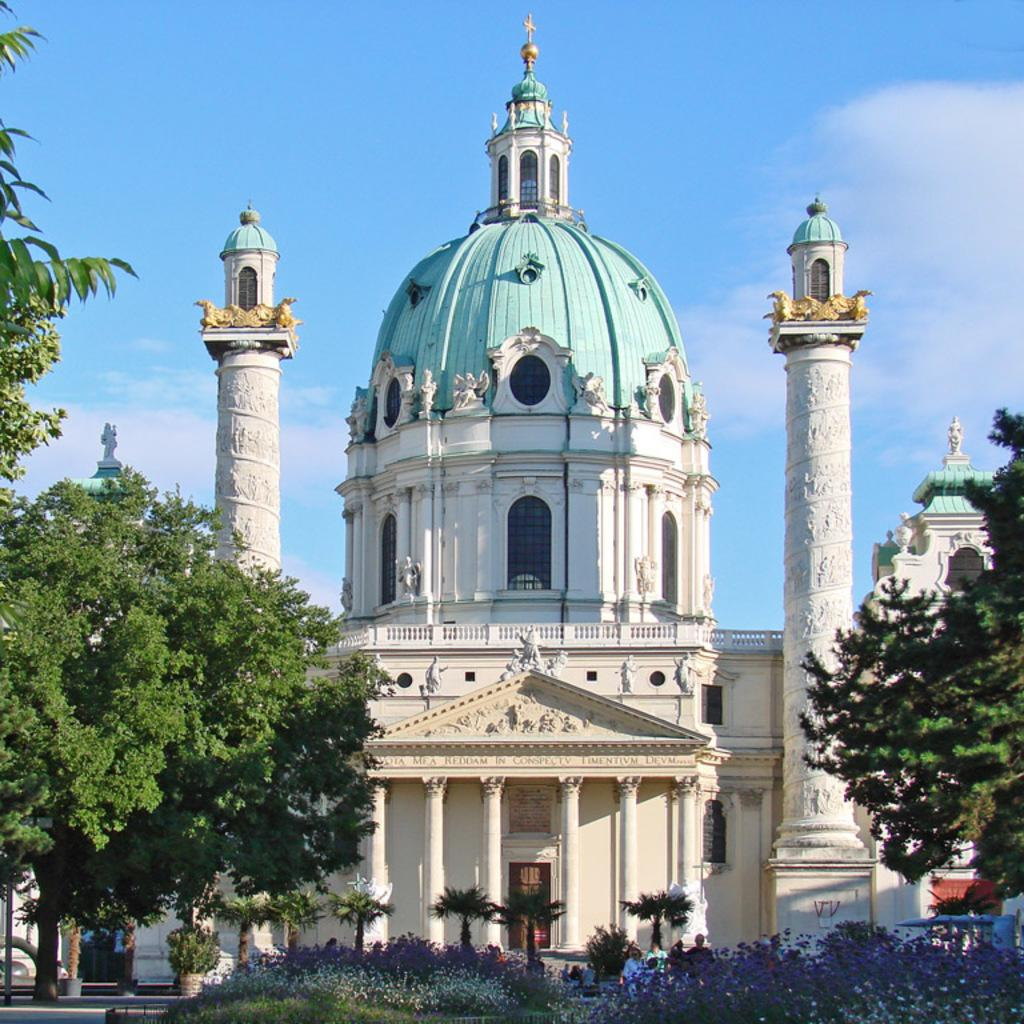What can be seen on the ground in the image? There are people on the ground in the image. What type of vegetation is present in the image? There are trees and plants with flowers in the image. What else can be seen in the image besides people and vegetation? There are objects in the image. What is visible in the background of the image? There are buildings and the sky in the background of the image. Can you tell me how many fingers the plants have in the image? There are no fingers present in the image, as the image features plants and not living beings with fingers. What type of conversation is happening between the plants in the image? There is no conversation happening between the plants in the image, as plants do not have the ability to talk. 